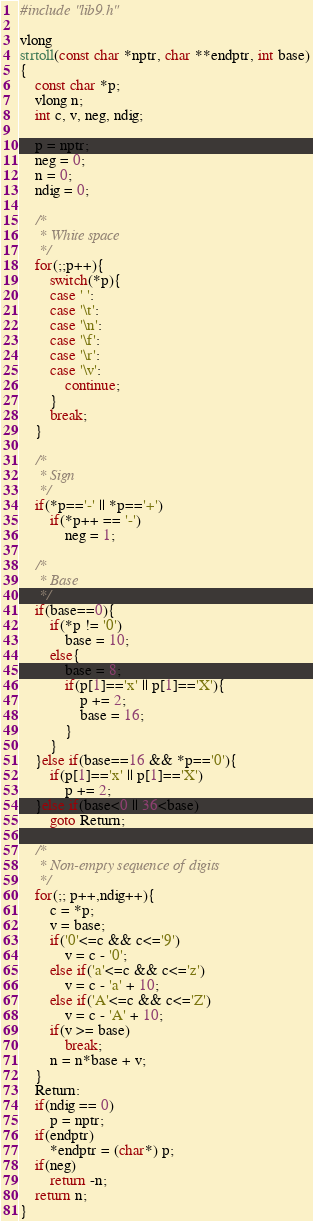Convert code to text. <code><loc_0><loc_0><loc_500><loc_500><_C_>#include "lib9.h"

vlong
strtoll(const char *nptr, char **endptr, int base)
{
	const char *p;
	vlong n;
	int c, v, neg, ndig;

	p = nptr;
	neg = 0;
	n = 0;
	ndig = 0;

	/*
	 * White space
	 */
	for(;;p++){
		switch(*p){
		case ' ':
		case '\t':
		case '\n':
		case '\f':
		case '\r':
		case '\v':
			continue;
		}
		break;
	}

	/*
	 * Sign
	 */
	if(*p=='-' || *p=='+')
		if(*p++ == '-')
			neg = 1;

	/*
	 * Base
	 */
	if(base==0){
		if(*p != '0')
			base = 10;
		else{
			base = 8;
			if(p[1]=='x' || p[1]=='X'){
				p += 2;
				base = 16;
			}
		}
	}else if(base==16 && *p=='0'){
		if(p[1]=='x' || p[1]=='X')
			p += 2;
	}else if(base<0 || 36<base)
		goto Return;

	/*
	 * Non-empty sequence of digits
	 */
	for(;; p++,ndig++){
		c = *p;
		v = base;
		if('0'<=c && c<='9')
			v = c - '0';
		else if('a'<=c && c<='z')
			v = c - 'a' + 10;
		else if('A'<=c && c<='Z')
			v = c - 'A' + 10;
		if(v >= base)
			break;
		n = n*base + v;
	}
    Return:
	if(ndig == 0)
		p = nptr;
	if(endptr)
		*endptr = (char*) p;
	if(neg)
		return -n;
	return n;
}
</code> 